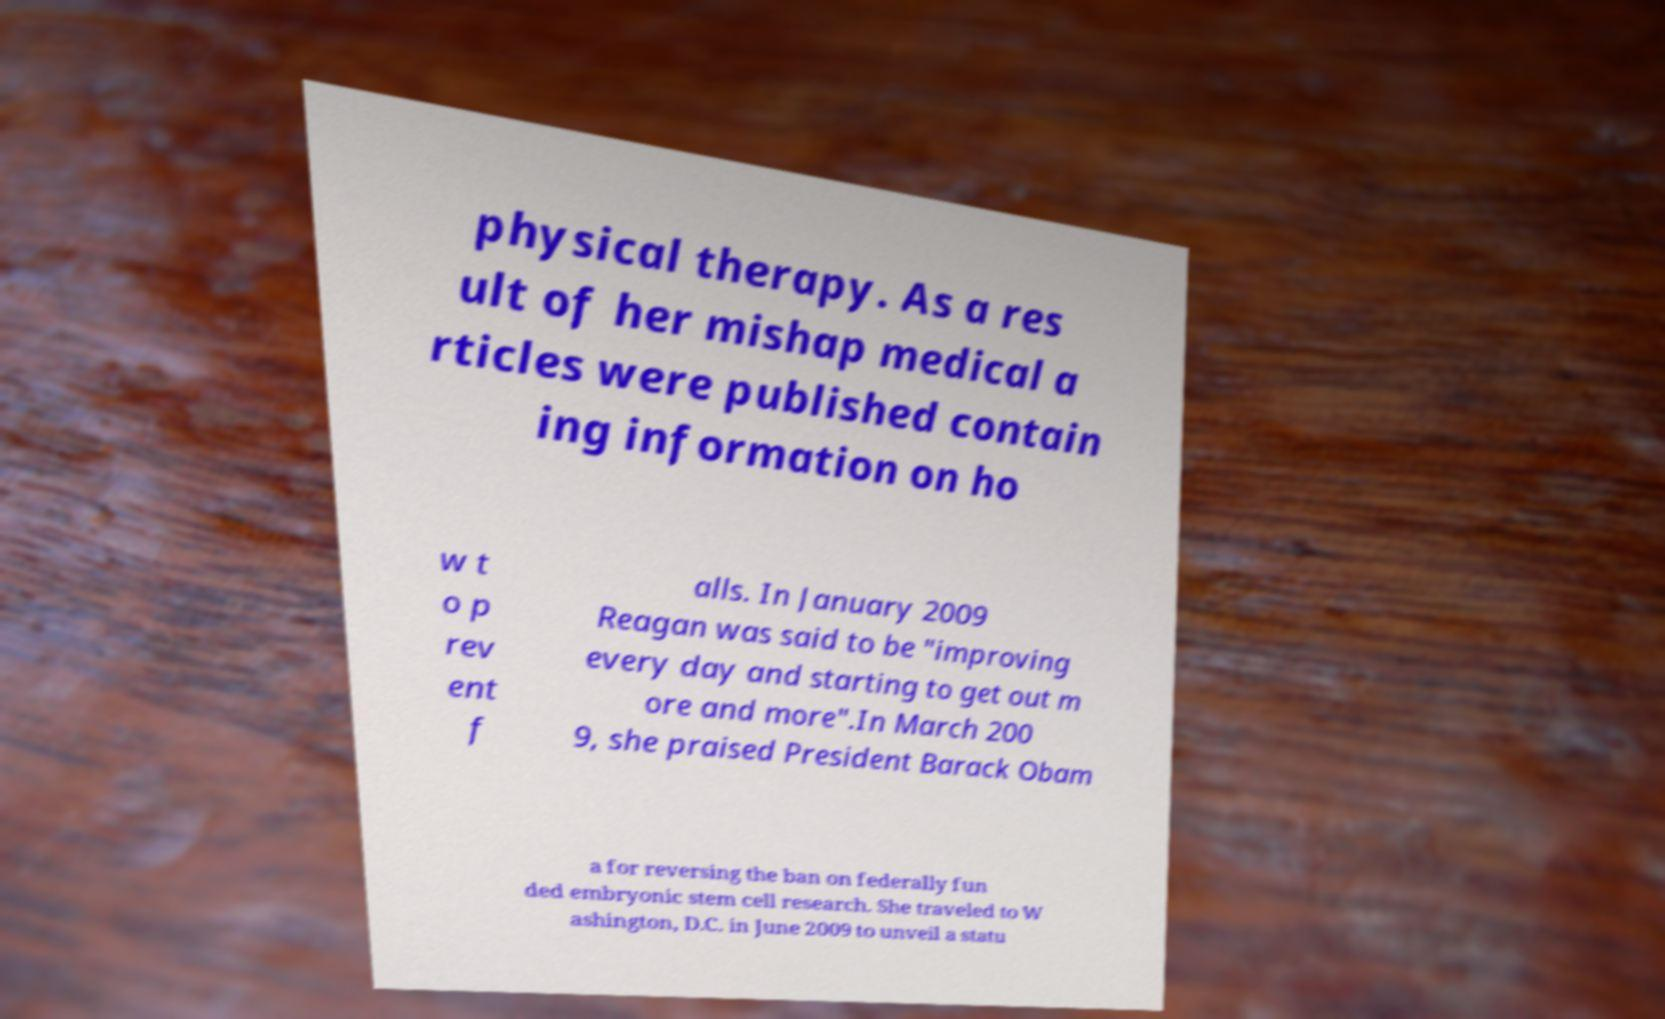Please read and relay the text visible in this image. What does it say? physical therapy. As a res ult of her mishap medical a rticles were published contain ing information on ho w t o p rev ent f alls. In January 2009 Reagan was said to be "improving every day and starting to get out m ore and more".In March 200 9, she praised President Barack Obam a for reversing the ban on federally fun ded embryonic stem cell research. She traveled to W ashington, D.C. in June 2009 to unveil a statu 